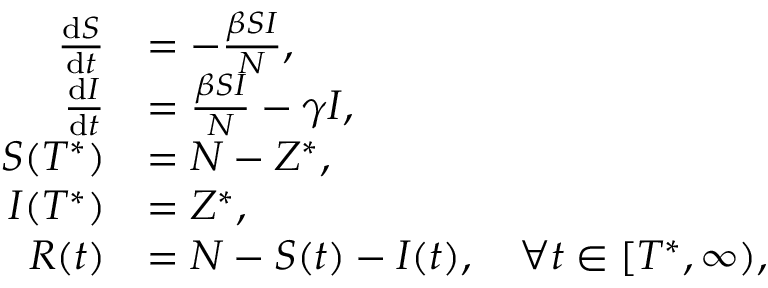Convert formula to latex. <formula><loc_0><loc_0><loc_500><loc_500>\begin{array} { r l } { \frac { { d } S } { { d } t } } & { = - \frac { \beta S I } { N } , } \\ { \frac { { d } I } { { d } t } } & { = \frac { \beta S I } { N } - \gamma I , } \\ { S ( T ^ { * } ) } & { = N - Z ^ { * } , } \\ { I ( T ^ { * } ) } & { = Z ^ { * } , } \\ { R ( t ) } & { = N - S ( t ) - I ( t ) , \quad \forall t \in [ T ^ { * } , \infty ) , } \end{array}</formula> 